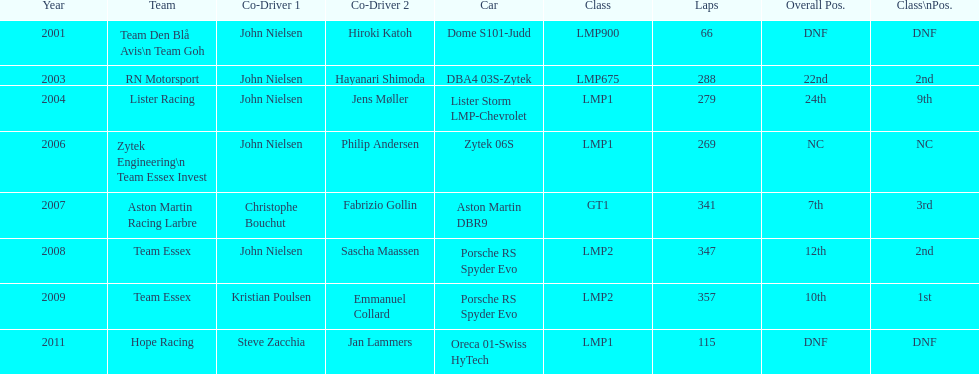Who was john nielsen co-driver for team lister in 2004? Jens Møller. 